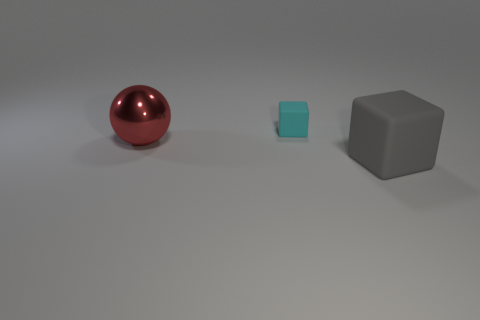Is there any other thing that is the same material as the red thing?
Keep it short and to the point. No. There is another large object that is made of the same material as the cyan object; what is its shape?
Give a very brief answer. Cube. What number of other objects are the same shape as the small object?
Keep it short and to the point. 1. How many green things are either small cubes or shiny cubes?
Your answer should be compact. 0. Does the large gray matte thing have the same shape as the small object?
Give a very brief answer. Yes. There is a rubber thing that is in front of the big red object; are there any gray cubes on the right side of it?
Give a very brief answer. No. Is the number of big metal objects that are behind the red object the same as the number of big brown metallic blocks?
Keep it short and to the point. Yes. What number of other things are there of the same size as the ball?
Your answer should be very brief. 1. Does the big thing right of the tiny cyan matte object have the same material as the block that is behind the large shiny sphere?
Offer a very short reply. Yes. There is a cube that is left of the large block in front of the big shiny thing; how big is it?
Your answer should be very brief. Small. 